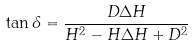Convert formula to latex. <formula><loc_0><loc_0><loc_500><loc_500>\tan \delta = \frac { D \Delta H } { H ^ { 2 } - H \Delta H + D ^ { 2 } }</formula> 